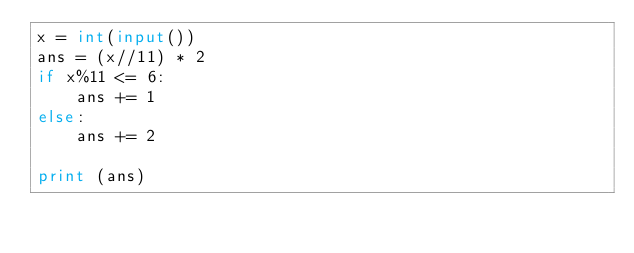Convert code to text. <code><loc_0><loc_0><loc_500><loc_500><_Python_>x = int(input())
ans = (x//11) * 2
if x%11 <= 6:
    ans += 1
else:
    ans += 2

print (ans)
</code> 